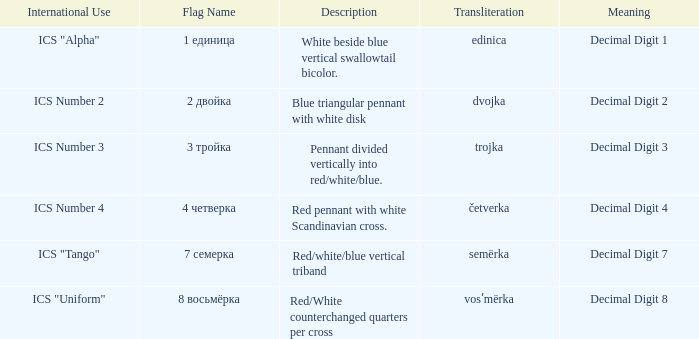What are the meanings of the flag whose name transliterates to dvojka? Decimal Digit 2. 